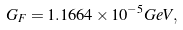<formula> <loc_0><loc_0><loc_500><loc_500>G _ { F } = 1 . 1 6 6 4 \times 1 0 ^ { - 5 } G e V ,</formula> 